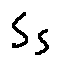<formula> <loc_0><loc_0><loc_500><loc_500>S _ { S }</formula> 